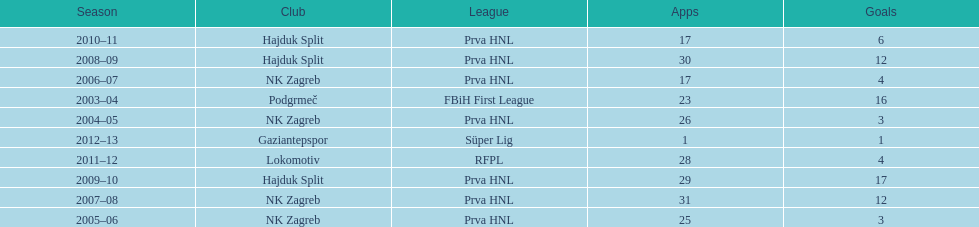What were the names of each club where more than 15 goals were scored in a single season? Podgrmeč, Hajduk Split. 